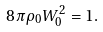<formula> <loc_0><loc_0><loc_500><loc_500>8 \pi \rho _ { 0 } W _ { 0 } ^ { 2 } = 1 .</formula> 